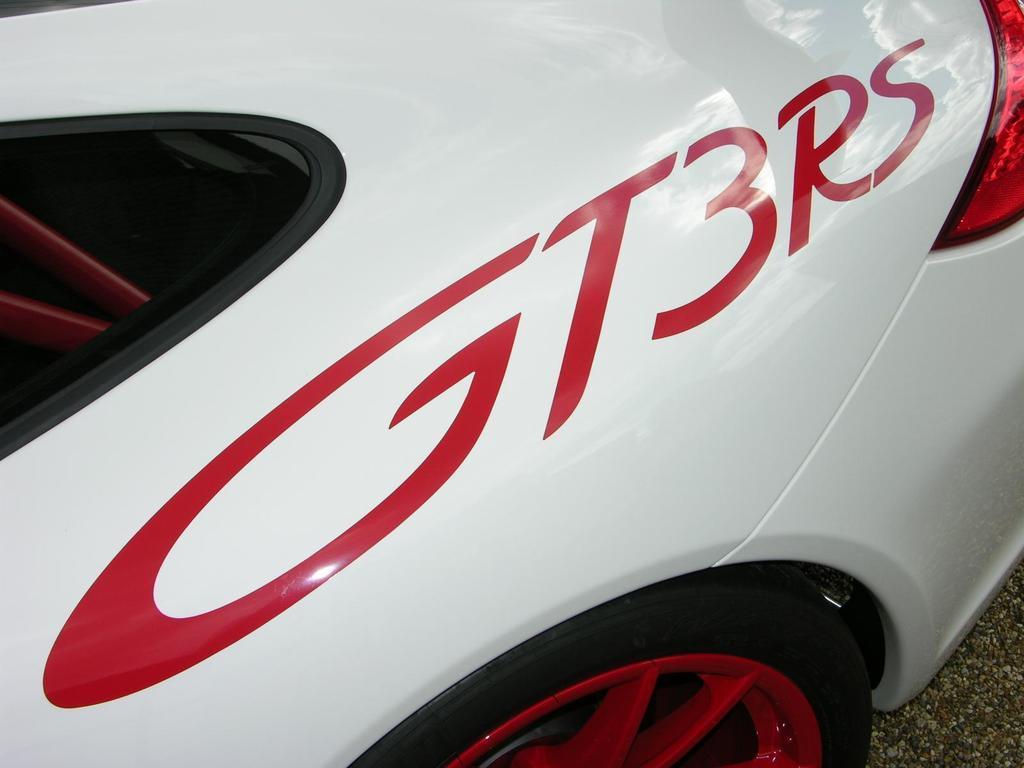Could you give a brief overview of what you see in this image? In this image we can see a car. At the bottom of the image there is road. 